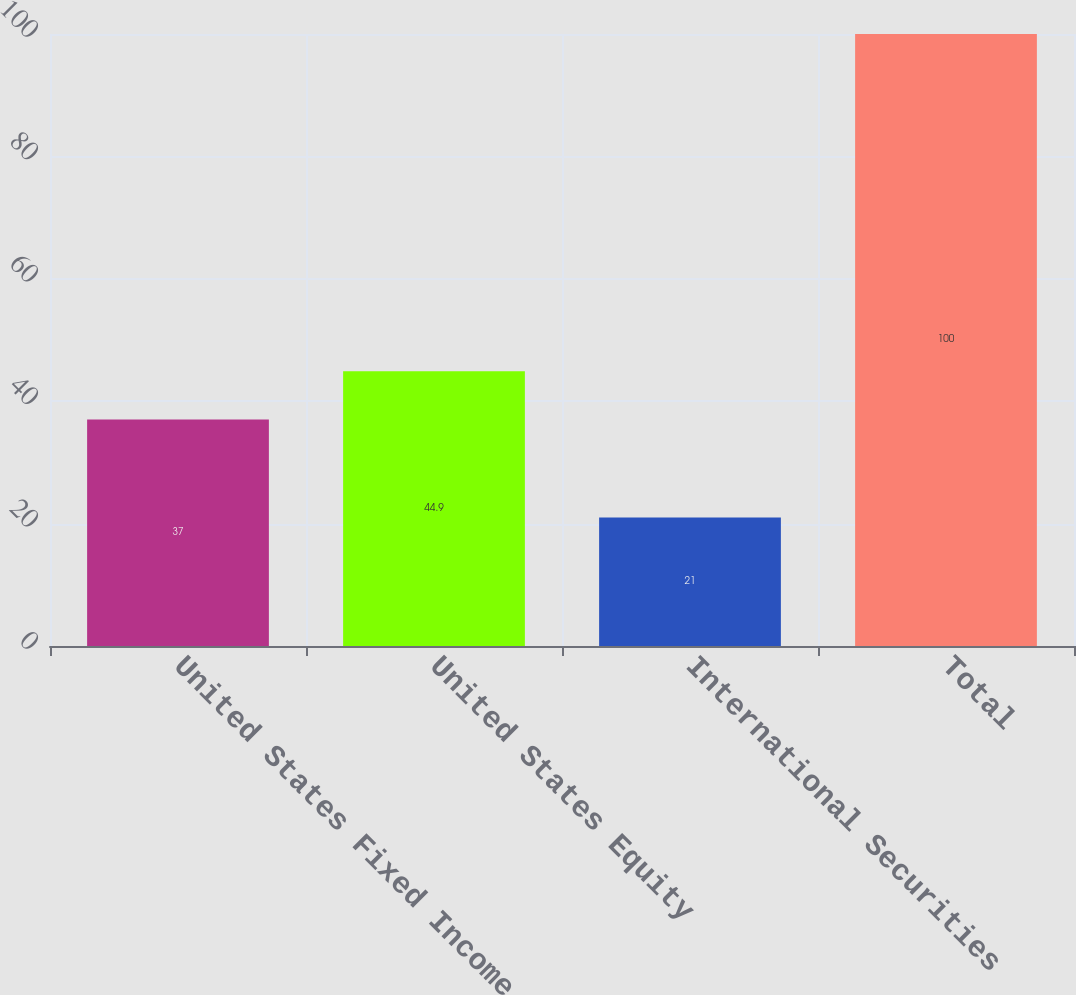Convert chart to OTSL. <chart><loc_0><loc_0><loc_500><loc_500><bar_chart><fcel>United States Fixed Income<fcel>United States Equity<fcel>International Securities<fcel>Total<nl><fcel>37<fcel>44.9<fcel>21<fcel>100<nl></chart> 